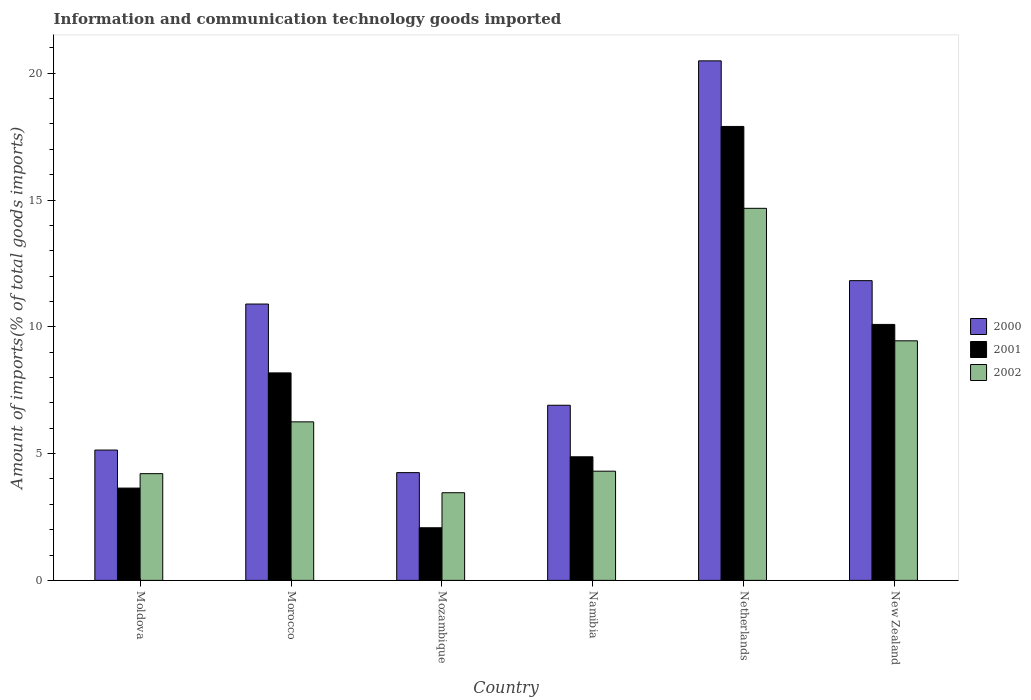How many different coloured bars are there?
Offer a terse response. 3. How many groups of bars are there?
Your answer should be compact. 6. How many bars are there on the 3rd tick from the right?
Offer a terse response. 3. What is the label of the 1st group of bars from the left?
Provide a succinct answer. Moldova. In how many cases, is the number of bars for a given country not equal to the number of legend labels?
Provide a short and direct response. 0. What is the amount of goods imported in 2000 in New Zealand?
Your answer should be compact. 11.82. Across all countries, what is the maximum amount of goods imported in 2002?
Your answer should be compact. 14.67. Across all countries, what is the minimum amount of goods imported in 2000?
Ensure brevity in your answer.  4.25. In which country was the amount of goods imported in 2002 minimum?
Provide a short and direct response. Mozambique. What is the total amount of goods imported in 2000 in the graph?
Ensure brevity in your answer.  59.51. What is the difference between the amount of goods imported in 2001 in Morocco and that in Netherlands?
Ensure brevity in your answer.  -9.72. What is the difference between the amount of goods imported in 2000 in Netherlands and the amount of goods imported in 2001 in Moldova?
Give a very brief answer. 16.85. What is the average amount of goods imported in 2000 per country?
Provide a short and direct response. 9.92. What is the difference between the amount of goods imported of/in 2000 and amount of goods imported of/in 2001 in Namibia?
Provide a short and direct response. 2.03. In how many countries, is the amount of goods imported in 2002 greater than 13 %?
Give a very brief answer. 1. What is the ratio of the amount of goods imported in 2002 in Mozambique to that in Namibia?
Keep it short and to the point. 0.8. Is the amount of goods imported in 2000 in Morocco less than that in Mozambique?
Provide a succinct answer. No. Is the difference between the amount of goods imported in 2000 in Morocco and Netherlands greater than the difference between the amount of goods imported in 2001 in Morocco and Netherlands?
Your answer should be compact. Yes. What is the difference between the highest and the second highest amount of goods imported in 2000?
Make the answer very short. -0.92. What is the difference between the highest and the lowest amount of goods imported in 2000?
Your answer should be very brief. 16.24. Is the sum of the amount of goods imported in 2002 in Netherlands and New Zealand greater than the maximum amount of goods imported in 2001 across all countries?
Your response must be concise. Yes. What does the 1st bar from the right in New Zealand represents?
Your answer should be compact. 2002. How many bars are there?
Your answer should be very brief. 18. Are all the bars in the graph horizontal?
Ensure brevity in your answer.  No. How many countries are there in the graph?
Your response must be concise. 6. Does the graph contain grids?
Provide a short and direct response. No. Where does the legend appear in the graph?
Provide a short and direct response. Center right. What is the title of the graph?
Your answer should be very brief. Information and communication technology goods imported. Does "1964" appear as one of the legend labels in the graph?
Make the answer very short. No. What is the label or title of the Y-axis?
Provide a short and direct response. Amount of imports(% of total goods imports). What is the Amount of imports(% of total goods imports) of 2000 in Moldova?
Your answer should be compact. 5.14. What is the Amount of imports(% of total goods imports) in 2001 in Moldova?
Your answer should be compact. 3.64. What is the Amount of imports(% of total goods imports) in 2002 in Moldova?
Your answer should be very brief. 4.21. What is the Amount of imports(% of total goods imports) of 2000 in Morocco?
Provide a short and direct response. 10.9. What is the Amount of imports(% of total goods imports) of 2001 in Morocco?
Offer a very short reply. 8.18. What is the Amount of imports(% of total goods imports) in 2002 in Morocco?
Your response must be concise. 6.25. What is the Amount of imports(% of total goods imports) in 2000 in Mozambique?
Offer a very short reply. 4.25. What is the Amount of imports(% of total goods imports) in 2001 in Mozambique?
Make the answer very short. 2.08. What is the Amount of imports(% of total goods imports) in 2002 in Mozambique?
Your answer should be compact. 3.46. What is the Amount of imports(% of total goods imports) in 2000 in Namibia?
Offer a very short reply. 6.91. What is the Amount of imports(% of total goods imports) of 2001 in Namibia?
Your answer should be very brief. 4.87. What is the Amount of imports(% of total goods imports) in 2002 in Namibia?
Keep it short and to the point. 4.31. What is the Amount of imports(% of total goods imports) in 2000 in Netherlands?
Provide a succinct answer. 20.49. What is the Amount of imports(% of total goods imports) of 2001 in Netherlands?
Provide a short and direct response. 17.9. What is the Amount of imports(% of total goods imports) in 2002 in Netherlands?
Offer a terse response. 14.67. What is the Amount of imports(% of total goods imports) in 2000 in New Zealand?
Your answer should be very brief. 11.82. What is the Amount of imports(% of total goods imports) of 2001 in New Zealand?
Ensure brevity in your answer.  10.1. What is the Amount of imports(% of total goods imports) in 2002 in New Zealand?
Your response must be concise. 9.45. Across all countries, what is the maximum Amount of imports(% of total goods imports) in 2000?
Offer a terse response. 20.49. Across all countries, what is the maximum Amount of imports(% of total goods imports) in 2001?
Keep it short and to the point. 17.9. Across all countries, what is the maximum Amount of imports(% of total goods imports) of 2002?
Give a very brief answer. 14.67. Across all countries, what is the minimum Amount of imports(% of total goods imports) in 2000?
Give a very brief answer. 4.25. Across all countries, what is the minimum Amount of imports(% of total goods imports) in 2001?
Ensure brevity in your answer.  2.08. Across all countries, what is the minimum Amount of imports(% of total goods imports) of 2002?
Your answer should be compact. 3.46. What is the total Amount of imports(% of total goods imports) of 2000 in the graph?
Your response must be concise. 59.51. What is the total Amount of imports(% of total goods imports) in 2001 in the graph?
Ensure brevity in your answer.  46.77. What is the total Amount of imports(% of total goods imports) in 2002 in the graph?
Your response must be concise. 42.35. What is the difference between the Amount of imports(% of total goods imports) in 2000 in Moldova and that in Morocco?
Make the answer very short. -5.76. What is the difference between the Amount of imports(% of total goods imports) in 2001 in Moldova and that in Morocco?
Provide a short and direct response. -4.54. What is the difference between the Amount of imports(% of total goods imports) of 2002 in Moldova and that in Morocco?
Your answer should be compact. -2.04. What is the difference between the Amount of imports(% of total goods imports) in 2000 in Moldova and that in Mozambique?
Make the answer very short. 0.89. What is the difference between the Amount of imports(% of total goods imports) in 2001 in Moldova and that in Mozambique?
Your response must be concise. 1.56. What is the difference between the Amount of imports(% of total goods imports) in 2002 in Moldova and that in Mozambique?
Keep it short and to the point. 0.75. What is the difference between the Amount of imports(% of total goods imports) in 2000 in Moldova and that in Namibia?
Make the answer very short. -1.77. What is the difference between the Amount of imports(% of total goods imports) of 2001 in Moldova and that in Namibia?
Your response must be concise. -1.23. What is the difference between the Amount of imports(% of total goods imports) in 2002 in Moldova and that in Namibia?
Ensure brevity in your answer.  -0.1. What is the difference between the Amount of imports(% of total goods imports) of 2000 in Moldova and that in Netherlands?
Your response must be concise. -15.35. What is the difference between the Amount of imports(% of total goods imports) in 2001 in Moldova and that in Netherlands?
Provide a short and direct response. -14.26. What is the difference between the Amount of imports(% of total goods imports) in 2002 in Moldova and that in Netherlands?
Offer a very short reply. -10.46. What is the difference between the Amount of imports(% of total goods imports) in 2000 in Moldova and that in New Zealand?
Provide a succinct answer. -6.68. What is the difference between the Amount of imports(% of total goods imports) of 2001 in Moldova and that in New Zealand?
Your answer should be compact. -6.45. What is the difference between the Amount of imports(% of total goods imports) in 2002 in Moldova and that in New Zealand?
Make the answer very short. -5.24. What is the difference between the Amount of imports(% of total goods imports) of 2000 in Morocco and that in Mozambique?
Provide a short and direct response. 6.65. What is the difference between the Amount of imports(% of total goods imports) of 2001 in Morocco and that in Mozambique?
Your answer should be compact. 6.11. What is the difference between the Amount of imports(% of total goods imports) in 2002 in Morocco and that in Mozambique?
Provide a short and direct response. 2.8. What is the difference between the Amount of imports(% of total goods imports) of 2000 in Morocco and that in Namibia?
Make the answer very short. 3.99. What is the difference between the Amount of imports(% of total goods imports) of 2001 in Morocco and that in Namibia?
Your answer should be compact. 3.31. What is the difference between the Amount of imports(% of total goods imports) of 2002 in Morocco and that in Namibia?
Offer a terse response. 1.95. What is the difference between the Amount of imports(% of total goods imports) of 2000 in Morocco and that in Netherlands?
Offer a terse response. -9.59. What is the difference between the Amount of imports(% of total goods imports) in 2001 in Morocco and that in Netherlands?
Offer a very short reply. -9.72. What is the difference between the Amount of imports(% of total goods imports) of 2002 in Morocco and that in Netherlands?
Keep it short and to the point. -8.42. What is the difference between the Amount of imports(% of total goods imports) of 2000 in Morocco and that in New Zealand?
Keep it short and to the point. -0.92. What is the difference between the Amount of imports(% of total goods imports) of 2001 in Morocco and that in New Zealand?
Your answer should be compact. -1.91. What is the difference between the Amount of imports(% of total goods imports) in 2002 in Morocco and that in New Zealand?
Offer a very short reply. -3.2. What is the difference between the Amount of imports(% of total goods imports) of 2000 in Mozambique and that in Namibia?
Your answer should be very brief. -2.66. What is the difference between the Amount of imports(% of total goods imports) in 2001 in Mozambique and that in Namibia?
Offer a terse response. -2.8. What is the difference between the Amount of imports(% of total goods imports) in 2002 in Mozambique and that in Namibia?
Give a very brief answer. -0.85. What is the difference between the Amount of imports(% of total goods imports) of 2000 in Mozambique and that in Netherlands?
Make the answer very short. -16.24. What is the difference between the Amount of imports(% of total goods imports) of 2001 in Mozambique and that in Netherlands?
Provide a succinct answer. -15.83. What is the difference between the Amount of imports(% of total goods imports) of 2002 in Mozambique and that in Netherlands?
Your answer should be very brief. -11.22. What is the difference between the Amount of imports(% of total goods imports) in 2000 in Mozambique and that in New Zealand?
Ensure brevity in your answer.  -7.57. What is the difference between the Amount of imports(% of total goods imports) in 2001 in Mozambique and that in New Zealand?
Provide a succinct answer. -8.02. What is the difference between the Amount of imports(% of total goods imports) in 2002 in Mozambique and that in New Zealand?
Keep it short and to the point. -5.99. What is the difference between the Amount of imports(% of total goods imports) of 2000 in Namibia and that in Netherlands?
Keep it short and to the point. -13.58. What is the difference between the Amount of imports(% of total goods imports) of 2001 in Namibia and that in Netherlands?
Give a very brief answer. -13.03. What is the difference between the Amount of imports(% of total goods imports) in 2002 in Namibia and that in Netherlands?
Give a very brief answer. -10.37. What is the difference between the Amount of imports(% of total goods imports) of 2000 in Namibia and that in New Zealand?
Your response must be concise. -4.91. What is the difference between the Amount of imports(% of total goods imports) of 2001 in Namibia and that in New Zealand?
Ensure brevity in your answer.  -5.22. What is the difference between the Amount of imports(% of total goods imports) in 2002 in Namibia and that in New Zealand?
Your response must be concise. -5.14. What is the difference between the Amount of imports(% of total goods imports) of 2000 in Netherlands and that in New Zealand?
Make the answer very short. 8.67. What is the difference between the Amount of imports(% of total goods imports) of 2001 in Netherlands and that in New Zealand?
Make the answer very short. 7.81. What is the difference between the Amount of imports(% of total goods imports) of 2002 in Netherlands and that in New Zealand?
Provide a short and direct response. 5.23. What is the difference between the Amount of imports(% of total goods imports) in 2000 in Moldova and the Amount of imports(% of total goods imports) in 2001 in Morocco?
Keep it short and to the point. -3.04. What is the difference between the Amount of imports(% of total goods imports) of 2000 in Moldova and the Amount of imports(% of total goods imports) of 2002 in Morocco?
Offer a very short reply. -1.11. What is the difference between the Amount of imports(% of total goods imports) of 2001 in Moldova and the Amount of imports(% of total goods imports) of 2002 in Morocco?
Keep it short and to the point. -2.61. What is the difference between the Amount of imports(% of total goods imports) of 2000 in Moldova and the Amount of imports(% of total goods imports) of 2001 in Mozambique?
Ensure brevity in your answer.  3.06. What is the difference between the Amount of imports(% of total goods imports) in 2000 in Moldova and the Amount of imports(% of total goods imports) in 2002 in Mozambique?
Ensure brevity in your answer.  1.68. What is the difference between the Amount of imports(% of total goods imports) of 2001 in Moldova and the Amount of imports(% of total goods imports) of 2002 in Mozambique?
Provide a short and direct response. 0.18. What is the difference between the Amount of imports(% of total goods imports) of 2000 in Moldova and the Amount of imports(% of total goods imports) of 2001 in Namibia?
Provide a succinct answer. 0.27. What is the difference between the Amount of imports(% of total goods imports) of 2000 in Moldova and the Amount of imports(% of total goods imports) of 2002 in Namibia?
Provide a short and direct response. 0.83. What is the difference between the Amount of imports(% of total goods imports) in 2001 in Moldova and the Amount of imports(% of total goods imports) in 2002 in Namibia?
Offer a very short reply. -0.67. What is the difference between the Amount of imports(% of total goods imports) in 2000 in Moldova and the Amount of imports(% of total goods imports) in 2001 in Netherlands?
Offer a very short reply. -12.76. What is the difference between the Amount of imports(% of total goods imports) of 2000 in Moldova and the Amount of imports(% of total goods imports) of 2002 in Netherlands?
Your answer should be compact. -9.53. What is the difference between the Amount of imports(% of total goods imports) of 2001 in Moldova and the Amount of imports(% of total goods imports) of 2002 in Netherlands?
Offer a very short reply. -11.03. What is the difference between the Amount of imports(% of total goods imports) of 2000 in Moldova and the Amount of imports(% of total goods imports) of 2001 in New Zealand?
Make the answer very short. -4.96. What is the difference between the Amount of imports(% of total goods imports) in 2000 in Moldova and the Amount of imports(% of total goods imports) in 2002 in New Zealand?
Give a very brief answer. -4.31. What is the difference between the Amount of imports(% of total goods imports) in 2001 in Moldova and the Amount of imports(% of total goods imports) in 2002 in New Zealand?
Ensure brevity in your answer.  -5.81. What is the difference between the Amount of imports(% of total goods imports) in 2000 in Morocco and the Amount of imports(% of total goods imports) in 2001 in Mozambique?
Give a very brief answer. 8.82. What is the difference between the Amount of imports(% of total goods imports) of 2000 in Morocco and the Amount of imports(% of total goods imports) of 2002 in Mozambique?
Give a very brief answer. 7.44. What is the difference between the Amount of imports(% of total goods imports) of 2001 in Morocco and the Amount of imports(% of total goods imports) of 2002 in Mozambique?
Keep it short and to the point. 4.73. What is the difference between the Amount of imports(% of total goods imports) of 2000 in Morocco and the Amount of imports(% of total goods imports) of 2001 in Namibia?
Make the answer very short. 6.02. What is the difference between the Amount of imports(% of total goods imports) in 2000 in Morocco and the Amount of imports(% of total goods imports) in 2002 in Namibia?
Give a very brief answer. 6.59. What is the difference between the Amount of imports(% of total goods imports) in 2001 in Morocco and the Amount of imports(% of total goods imports) in 2002 in Namibia?
Your answer should be very brief. 3.88. What is the difference between the Amount of imports(% of total goods imports) in 2000 in Morocco and the Amount of imports(% of total goods imports) in 2001 in Netherlands?
Your answer should be compact. -7. What is the difference between the Amount of imports(% of total goods imports) in 2000 in Morocco and the Amount of imports(% of total goods imports) in 2002 in Netherlands?
Give a very brief answer. -3.77. What is the difference between the Amount of imports(% of total goods imports) in 2001 in Morocco and the Amount of imports(% of total goods imports) in 2002 in Netherlands?
Your answer should be compact. -6.49. What is the difference between the Amount of imports(% of total goods imports) in 2000 in Morocco and the Amount of imports(% of total goods imports) in 2001 in New Zealand?
Ensure brevity in your answer.  0.8. What is the difference between the Amount of imports(% of total goods imports) of 2000 in Morocco and the Amount of imports(% of total goods imports) of 2002 in New Zealand?
Offer a very short reply. 1.45. What is the difference between the Amount of imports(% of total goods imports) of 2001 in Morocco and the Amount of imports(% of total goods imports) of 2002 in New Zealand?
Ensure brevity in your answer.  -1.26. What is the difference between the Amount of imports(% of total goods imports) of 2000 in Mozambique and the Amount of imports(% of total goods imports) of 2001 in Namibia?
Offer a terse response. -0.62. What is the difference between the Amount of imports(% of total goods imports) of 2000 in Mozambique and the Amount of imports(% of total goods imports) of 2002 in Namibia?
Your response must be concise. -0.06. What is the difference between the Amount of imports(% of total goods imports) in 2001 in Mozambique and the Amount of imports(% of total goods imports) in 2002 in Namibia?
Provide a short and direct response. -2.23. What is the difference between the Amount of imports(% of total goods imports) in 2000 in Mozambique and the Amount of imports(% of total goods imports) in 2001 in Netherlands?
Give a very brief answer. -13.65. What is the difference between the Amount of imports(% of total goods imports) in 2000 in Mozambique and the Amount of imports(% of total goods imports) in 2002 in Netherlands?
Give a very brief answer. -10.42. What is the difference between the Amount of imports(% of total goods imports) of 2001 in Mozambique and the Amount of imports(% of total goods imports) of 2002 in Netherlands?
Offer a terse response. -12.6. What is the difference between the Amount of imports(% of total goods imports) in 2000 in Mozambique and the Amount of imports(% of total goods imports) in 2001 in New Zealand?
Your answer should be very brief. -5.84. What is the difference between the Amount of imports(% of total goods imports) in 2000 in Mozambique and the Amount of imports(% of total goods imports) in 2002 in New Zealand?
Ensure brevity in your answer.  -5.2. What is the difference between the Amount of imports(% of total goods imports) of 2001 in Mozambique and the Amount of imports(% of total goods imports) of 2002 in New Zealand?
Ensure brevity in your answer.  -7.37. What is the difference between the Amount of imports(% of total goods imports) of 2000 in Namibia and the Amount of imports(% of total goods imports) of 2001 in Netherlands?
Provide a succinct answer. -11. What is the difference between the Amount of imports(% of total goods imports) in 2000 in Namibia and the Amount of imports(% of total goods imports) in 2002 in Netherlands?
Your answer should be compact. -7.77. What is the difference between the Amount of imports(% of total goods imports) of 2001 in Namibia and the Amount of imports(% of total goods imports) of 2002 in Netherlands?
Offer a very short reply. -9.8. What is the difference between the Amount of imports(% of total goods imports) in 2000 in Namibia and the Amount of imports(% of total goods imports) in 2001 in New Zealand?
Ensure brevity in your answer.  -3.19. What is the difference between the Amount of imports(% of total goods imports) in 2000 in Namibia and the Amount of imports(% of total goods imports) in 2002 in New Zealand?
Provide a short and direct response. -2.54. What is the difference between the Amount of imports(% of total goods imports) in 2001 in Namibia and the Amount of imports(% of total goods imports) in 2002 in New Zealand?
Make the answer very short. -4.57. What is the difference between the Amount of imports(% of total goods imports) in 2000 in Netherlands and the Amount of imports(% of total goods imports) in 2001 in New Zealand?
Your answer should be compact. 10.39. What is the difference between the Amount of imports(% of total goods imports) of 2000 in Netherlands and the Amount of imports(% of total goods imports) of 2002 in New Zealand?
Offer a very short reply. 11.04. What is the difference between the Amount of imports(% of total goods imports) in 2001 in Netherlands and the Amount of imports(% of total goods imports) in 2002 in New Zealand?
Give a very brief answer. 8.46. What is the average Amount of imports(% of total goods imports) of 2000 per country?
Provide a succinct answer. 9.92. What is the average Amount of imports(% of total goods imports) in 2001 per country?
Provide a succinct answer. 7.8. What is the average Amount of imports(% of total goods imports) in 2002 per country?
Offer a terse response. 7.06. What is the difference between the Amount of imports(% of total goods imports) of 2000 and Amount of imports(% of total goods imports) of 2001 in Moldova?
Provide a short and direct response. 1.5. What is the difference between the Amount of imports(% of total goods imports) of 2000 and Amount of imports(% of total goods imports) of 2002 in Moldova?
Your answer should be very brief. 0.93. What is the difference between the Amount of imports(% of total goods imports) in 2001 and Amount of imports(% of total goods imports) in 2002 in Moldova?
Your answer should be compact. -0.57. What is the difference between the Amount of imports(% of total goods imports) in 2000 and Amount of imports(% of total goods imports) in 2001 in Morocco?
Provide a short and direct response. 2.72. What is the difference between the Amount of imports(% of total goods imports) in 2000 and Amount of imports(% of total goods imports) in 2002 in Morocco?
Offer a very short reply. 4.65. What is the difference between the Amount of imports(% of total goods imports) in 2001 and Amount of imports(% of total goods imports) in 2002 in Morocco?
Your answer should be compact. 1.93. What is the difference between the Amount of imports(% of total goods imports) in 2000 and Amount of imports(% of total goods imports) in 2001 in Mozambique?
Provide a short and direct response. 2.17. What is the difference between the Amount of imports(% of total goods imports) in 2000 and Amount of imports(% of total goods imports) in 2002 in Mozambique?
Your response must be concise. 0.79. What is the difference between the Amount of imports(% of total goods imports) in 2001 and Amount of imports(% of total goods imports) in 2002 in Mozambique?
Keep it short and to the point. -1.38. What is the difference between the Amount of imports(% of total goods imports) in 2000 and Amount of imports(% of total goods imports) in 2001 in Namibia?
Ensure brevity in your answer.  2.03. What is the difference between the Amount of imports(% of total goods imports) in 2000 and Amount of imports(% of total goods imports) in 2002 in Namibia?
Your response must be concise. 2.6. What is the difference between the Amount of imports(% of total goods imports) of 2001 and Amount of imports(% of total goods imports) of 2002 in Namibia?
Provide a succinct answer. 0.57. What is the difference between the Amount of imports(% of total goods imports) in 2000 and Amount of imports(% of total goods imports) in 2001 in Netherlands?
Your answer should be very brief. 2.59. What is the difference between the Amount of imports(% of total goods imports) of 2000 and Amount of imports(% of total goods imports) of 2002 in Netherlands?
Your answer should be very brief. 5.82. What is the difference between the Amount of imports(% of total goods imports) of 2001 and Amount of imports(% of total goods imports) of 2002 in Netherlands?
Your response must be concise. 3.23. What is the difference between the Amount of imports(% of total goods imports) of 2000 and Amount of imports(% of total goods imports) of 2001 in New Zealand?
Keep it short and to the point. 1.73. What is the difference between the Amount of imports(% of total goods imports) of 2000 and Amount of imports(% of total goods imports) of 2002 in New Zealand?
Make the answer very short. 2.37. What is the difference between the Amount of imports(% of total goods imports) in 2001 and Amount of imports(% of total goods imports) in 2002 in New Zealand?
Provide a short and direct response. 0.65. What is the ratio of the Amount of imports(% of total goods imports) in 2000 in Moldova to that in Morocco?
Ensure brevity in your answer.  0.47. What is the ratio of the Amount of imports(% of total goods imports) of 2001 in Moldova to that in Morocco?
Make the answer very short. 0.44. What is the ratio of the Amount of imports(% of total goods imports) of 2002 in Moldova to that in Morocco?
Provide a short and direct response. 0.67. What is the ratio of the Amount of imports(% of total goods imports) of 2000 in Moldova to that in Mozambique?
Keep it short and to the point. 1.21. What is the ratio of the Amount of imports(% of total goods imports) in 2001 in Moldova to that in Mozambique?
Offer a very short reply. 1.75. What is the ratio of the Amount of imports(% of total goods imports) of 2002 in Moldova to that in Mozambique?
Give a very brief answer. 1.22. What is the ratio of the Amount of imports(% of total goods imports) in 2000 in Moldova to that in Namibia?
Provide a succinct answer. 0.74. What is the ratio of the Amount of imports(% of total goods imports) of 2001 in Moldova to that in Namibia?
Provide a short and direct response. 0.75. What is the ratio of the Amount of imports(% of total goods imports) of 2002 in Moldova to that in Namibia?
Provide a succinct answer. 0.98. What is the ratio of the Amount of imports(% of total goods imports) in 2000 in Moldova to that in Netherlands?
Your response must be concise. 0.25. What is the ratio of the Amount of imports(% of total goods imports) in 2001 in Moldova to that in Netherlands?
Make the answer very short. 0.2. What is the ratio of the Amount of imports(% of total goods imports) of 2002 in Moldova to that in Netherlands?
Ensure brevity in your answer.  0.29. What is the ratio of the Amount of imports(% of total goods imports) in 2000 in Moldova to that in New Zealand?
Provide a succinct answer. 0.43. What is the ratio of the Amount of imports(% of total goods imports) of 2001 in Moldova to that in New Zealand?
Provide a short and direct response. 0.36. What is the ratio of the Amount of imports(% of total goods imports) of 2002 in Moldova to that in New Zealand?
Make the answer very short. 0.45. What is the ratio of the Amount of imports(% of total goods imports) of 2000 in Morocco to that in Mozambique?
Provide a succinct answer. 2.56. What is the ratio of the Amount of imports(% of total goods imports) in 2001 in Morocco to that in Mozambique?
Give a very brief answer. 3.94. What is the ratio of the Amount of imports(% of total goods imports) in 2002 in Morocco to that in Mozambique?
Your response must be concise. 1.81. What is the ratio of the Amount of imports(% of total goods imports) of 2000 in Morocco to that in Namibia?
Your answer should be compact. 1.58. What is the ratio of the Amount of imports(% of total goods imports) in 2001 in Morocco to that in Namibia?
Make the answer very short. 1.68. What is the ratio of the Amount of imports(% of total goods imports) of 2002 in Morocco to that in Namibia?
Your answer should be very brief. 1.45. What is the ratio of the Amount of imports(% of total goods imports) of 2000 in Morocco to that in Netherlands?
Your answer should be very brief. 0.53. What is the ratio of the Amount of imports(% of total goods imports) of 2001 in Morocco to that in Netherlands?
Give a very brief answer. 0.46. What is the ratio of the Amount of imports(% of total goods imports) of 2002 in Morocco to that in Netherlands?
Your response must be concise. 0.43. What is the ratio of the Amount of imports(% of total goods imports) in 2000 in Morocco to that in New Zealand?
Keep it short and to the point. 0.92. What is the ratio of the Amount of imports(% of total goods imports) in 2001 in Morocco to that in New Zealand?
Provide a succinct answer. 0.81. What is the ratio of the Amount of imports(% of total goods imports) in 2002 in Morocco to that in New Zealand?
Your response must be concise. 0.66. What is the ratio of the Amount of imports(% of total goods imports) in 2000 in Mozambique to that in Namibia?
Keep it short and to the point. 0.62. What is the ratio of the Amount of imports(% of total goods imports) of 2001 in Mozambique to that in Namibia?
Provide a succinct answer. 0.43. What is the ratio of the Amount of imports(% of total goods imports) of 2002 in Mozambique to that in Namibia?
Keep it short and to the point. 0.8. What is the ratio of the Amount of imports(% of total goods imports) of 2000 in Mozambique to that in Netherlands?
Offer a very short reply. 0.21. What is the ratio of the Amount of imports(% of total goods imports) of 2001 in Mozambique to that in Netherlands?
Your answer should be compact. 0.12. What is the ratio of the Amount of imports(% of total goods imports) in 2002 in Mozambique to that in Netherlands?
Keep it short and to the point. 0.24. What is the ratio of the Amount of imports(% of total goods imports) of 2000 in Mozambique to that in New Zealand?
Make the answer very short. 0.36. What is the ratio of the Amount of imports(% of total goods imports) in 2001 in Mozambique to that in New Zealand?
Your answer should be very brief. 0.21. What is the ratio of the Amount of imports(% of total goods imports) of 2002 in Mozambique to that in New Zealand?
Provide a succinct answer. 0.37. What is the ratio of the Amount of imports(% of total goods imports) of 2000 in Namibia to that in Netherlands?
Keep it short and to the point. 0.34. What is the ratio of the Amount of imports(% of total goods imports) in 2001 in Namibia to that in Netherlands?
Offer a very short reply. 0.27. What is the ratio of the Amount of imports(% of total goods imports) in 2002 in Namibia to that in Netherlands?
Offer a very short reply. 0.29. What is the ratio of the Amount of imports(% of total goods imports) of 2000 in Namibia to that in New Zealand?
Your response must be concise. 0.58. What is the ratio of the Amount of imports(% of total goods imports) of 2001 in Namibia to that in New Zealand?
Provide a short and direct response. 0.48. What is the ratio of the Amount of imports(% of total goods imports) in 2002 in Namibia to that in New Zealand?
Provide a succinct answer. 0.46. What is the ratio of the Amount of imports(% of total goods imports) in 2000 in Netherlands to that in New Zealand?
Ensure brevity in your answer.  1.73. What is the ratio of the Amount of imports(% of total goods imports) of 2001 in Netherlands to that in New Zealand?
Give a very brief answer. 1.77. What is the ratio of the Amount of imports(% of total goods imports) in 2002 in Netherlands to that in New Zealand?
Provide a short and direct response. 1.55. What is the difference between the highest and the second highest Amount of imports(% of total goods imports) of 2000?
Make the answer very short. 8.67. What is the difference between the highest and the second highest Amount of imports(% of total goods imports) of 2001?
Your answer should be very brief. 7.81. What is the difference between the highest and the second highest Amount of imports(% of total goods imports) in 2002?
Make the answer very short. 5.23. What is the difference between the highest and the lowest Amount of imports(% of total goods imports) in 2000?
Give a very brief answer. 16.24. What is the difference between the highest and the lowest Amount of imports(% of total goods imports) of 2001?
Make the answer very short. 15.83. What is the difference between the highest and the lowest Amount of imports(% of total goods imports) of 2002?
Your response must be concise. 11.22. 